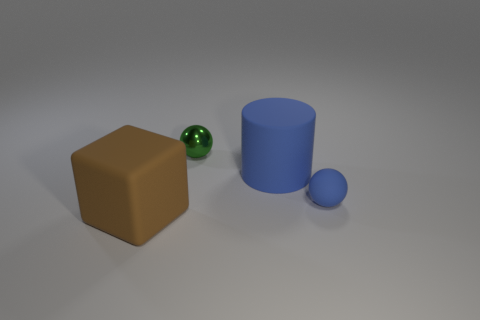Add 1 large rubber things. How many objects exist? 5 Subtract all blocks. How many objects are left? 3 Add 2 tiny blue rubber balls. How many tiny blue rubber balls exist? 3 Subtract 1 blue cylinders. How many objects are left? 3 Subtract all tiny spheres. Subtract all tiny cyan rubber cylinders. How many objects are left? 2 Add 1 metallic balls. How many metallic balls are left? 2 